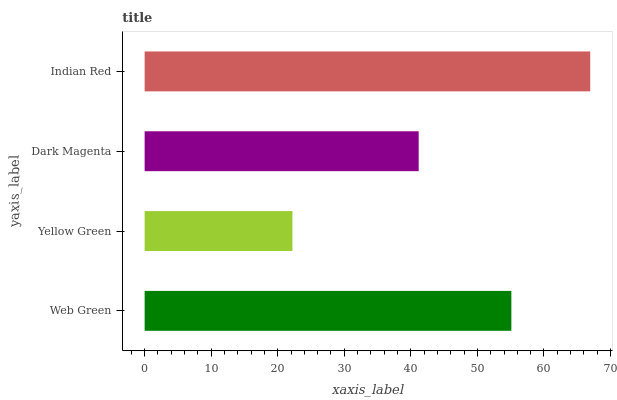Is Yellow Green the minimum?
Answer yes or no. Yes. Is Indian Red the maximum?
Answer yes or no. Yes. Is Dark Magenta the minimum?
Answer yes or no. No. Is Dark Magenta the maximum?
Answer yes or no. No. Is Dark Magenta greater than Yellow Green?
Answer yes or no. Yes. Is Yellow Green less than Dark Magenta?
Answer yes or no. Yes. Is Yellow Green greater than Dark Magenta?
Answer yes or no. No. Is Dark Magenta less than Yellow Green?
Answer yes or no. No. Is Web Green the high median?
Answer yes or no. Yes. Is Dark Magenta the low median?
Answer yes or no. Yes. Is Indian Red the high median?
Answer yes or no. No. Is Indian Red the low median?
Answer yes or no. No. 